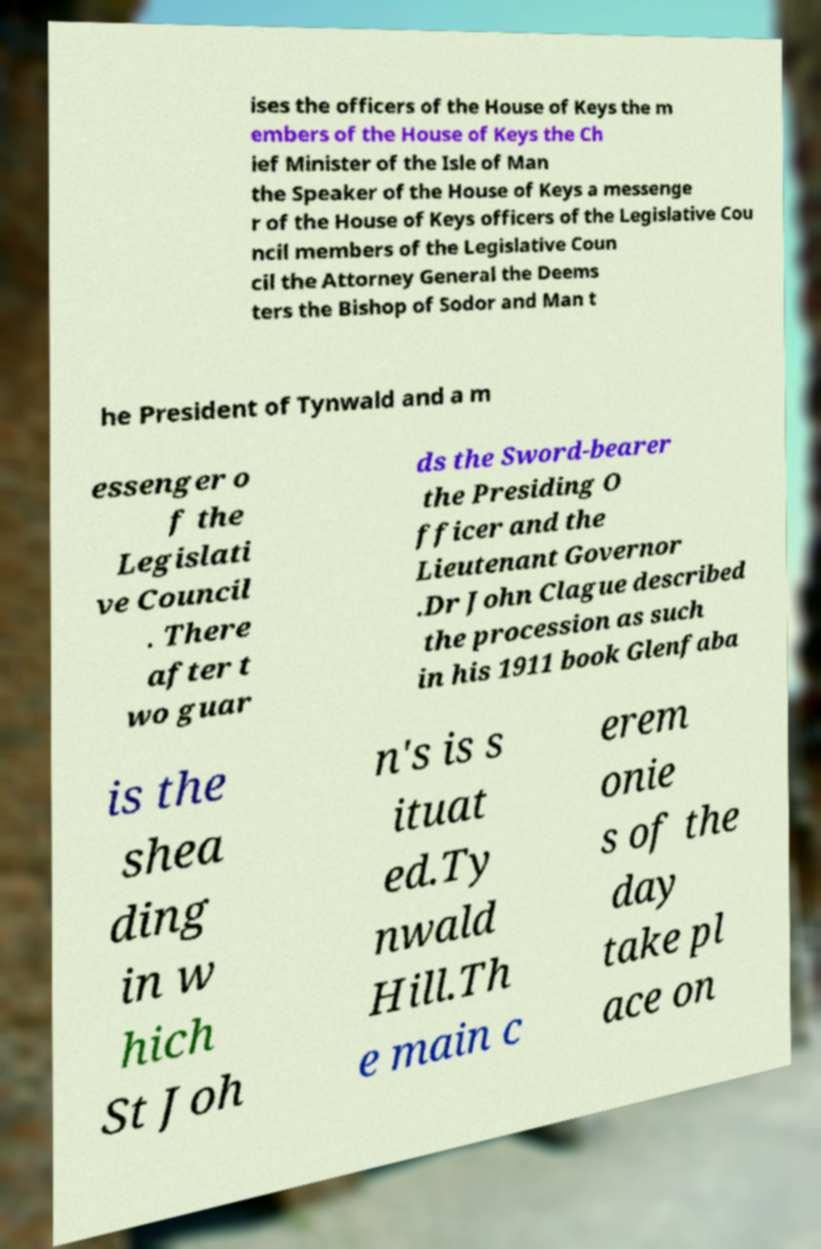Could you assist in decoding the text presented in this image and type it out clearly? ises the officers of the House of Keys the m embers of the House of Keys the Ch ief Minister of the Isle of Man the Speaker of the House of Keys a messenge r of the House of Keys officers of the Legislative Cou ncil members of the Legislative Coun cil the Attorney General the Deems ters the Bishop of Sodor and Man t he President of Tynwald and a m essenger o f the Legislati ve Council . There after t wo guar ds the Sword-bearer the Presiding O fficer and the Lieutenant Governor .Dr John Clague described the procession as such in his 1911 book Glenfaba is the shea ding in w hich St Joh n's is s ituat ed.Ty nwald Hill.Th e main c erem onie s of the day take pl ace on 